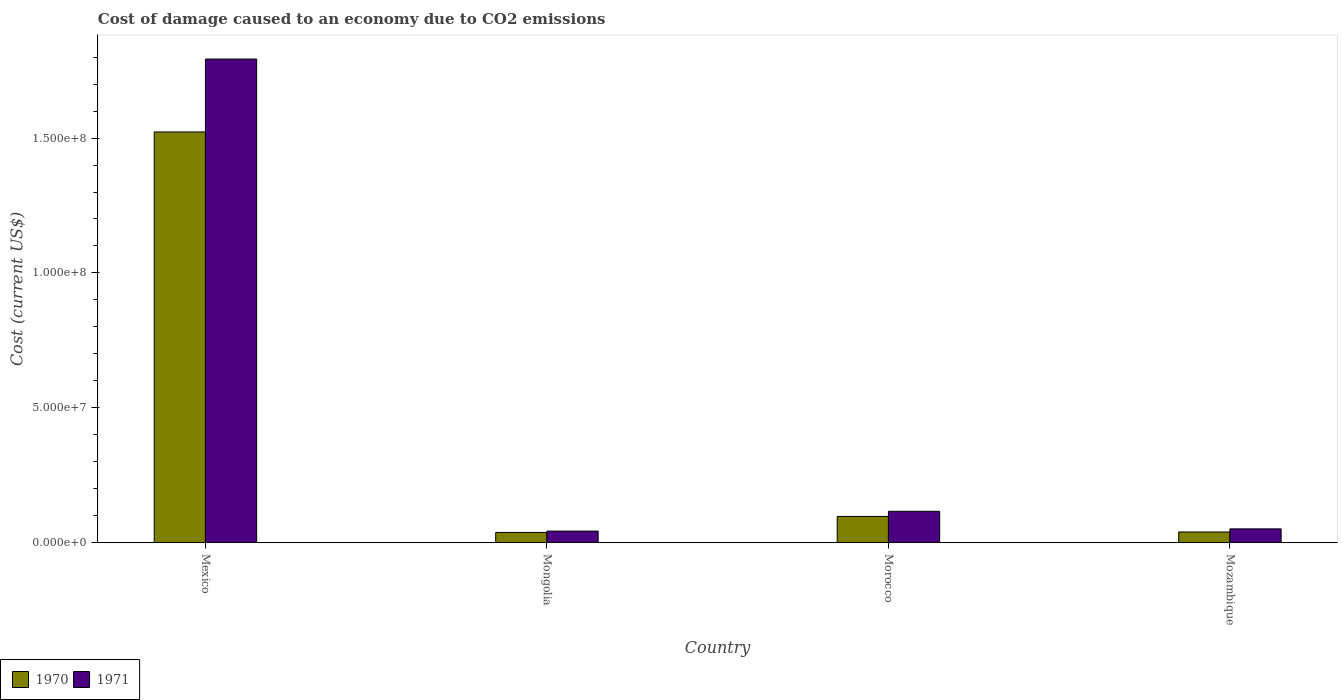How many different coloured bars are there?
Keep it short and to the point. 2. Are the number of bars per tick equal to the number of legend labels?
Offer a very short reply. Yes. How many bars are there on the 4th tick from the right?
Provide a short and direct response. 2. What is the label of the 4th group of bars from the left?
Ensure brevity in your answer.  Mozambique. In how many cases, is the number of bars for a given country not equal to the number of legend labels?
Your answer should be very brief. 0. What is the cost of damage caused due to CO2 emissisons in 1970 in Mongolia?
Provide a succinct answer. 3.80e+06. Across all countries, what is the maximum cost of damage caused due to CO2 emissisons in 1970?
Your answer should be compact. 1.52e+08. Across all countries, what is the minimum cost of damage caused due to CO2 emissisons in 1970?
Make the answer very short. 3.80e+06. In which country was the cost of damage caused due to CO2 emissisons in 1971 minimum?
Give a very brief answer. Mongolia. What is the total cost of damage caused due to CO2 emissisons in 1971 in the graph?
Your response must be concise. 2.00e+08. What is the difference between the cost of damage caused due to CO2 emissisons in 1970 in Mongolia and that in Morocco?
Ensure brevity in your answer.  -5.93e+06. What is the difference between the cost of damage caused due to CO2 emissisons in 1971 in Morocco and the cost of damage caused due to CO2 emissisons in 1970 in Mozambique?
Your response must be concise. 7.66e+06. What is the average cost of damage caused due to CO2 emissisons in 1971 per country?
Offer a terse response. 5.01e+07. What is the difference between the cost of damage caused due to CO2 emissisons of/in 1971 and cost of damage caused due to CO2 emissisons of/in 1970 in Mongolia?
Make the answer very short. 5.05e+05. In how many countries, is the cost of damage caused due to CO2 emissisons in 1971 greater than 90000000 US$?
Provide a succinct answer. 1. What is the ratio of the cost of damage caused due to CO2 emissisons in 1971 in Mexico to that in Morocco?
Provide a succinct answer. 15.4. Is the difference between the cost of damage caused due to CO2 emissisons in 1971 in Mexico and Mongolia greater than the difference between the cost of damage caused due to CO2 emissisons in 1970 in Mexico and Mongolia?
Offer a very short reply. Yes. What is the difference between the highest and the second highest cost of damage caused due to CO2 emissisons in 1971?
Your response must be concise. 1.68e+08. What is the difference between the highest and the lowest cost of damage caused due to CO2 emissisons in 1970?
Offer a very short reply. 1.48e+08. In how many countries, is the cost of damage caused due to CO2 emissisons in 1971 greater than the average cost of damage caused due to CO2 emissisons in 1971 taken over all countries?
Your response must be concise. 1. What does the 1st bar from the left in Mongolia represents?
Make the answer very short. 1970. What does the 2nd bar from the right in Mexico represents?
Your answer should be very brief. 1970. How many bars are there?
Give a very brief answer. 8. Are all the bars in the graph horizontal?
Your response must be concise. No. How many countries are there in the graph?
Provide a succinct answer. 4. Are the values on the major ticks of Y-axis written in scientific E-notation?
Your response must be concise. Yes. Where does the legend appear in the graph?
Provide a succinct answer. Bottom left. How many legend labels are there?
Ensure brevity in your answer.  2. How are the legend labels stacked?
Your answer should be compact. Horizontal. What is the title of the graph?
Make the answer very short. Cost of damage caused to an economy due to CO2 emissions. What is the label or title of the Y-axis?
Your answer should be compact. Cost (current US$). What is the Cost (current US$) in 1970 in Mexico?
Ensure brevity in your answer.  1.52e+08. What is the Cost (current US$) in 1971 in Mexico?
Your response must be concise. 1.79e+08. What is the Cost (current US$) in 1970 in Mongolia?
Provide a succinct answer. 3.80e+06. What is the Cost (current US$) in 1971 in Mongolia?
Provide a succinct answer. 4.31e+06. What is the Cost (current US$) of 1970 in Morocco?
Provide a short and direct response. 9.74e+06. What is the Cost (current US$) in 1971 in Morocco?
Provide a short and direct response. 1.16e+07. What is the Cost (current US$) in 1970 in Mozambique?
Give a very brief answer. 3.98e+06. What is the Cost (current US$) of 1971 in Mozambique?
Your response must be concise. 5.13e+06. Across all countries, what is the maximum Cost (current US$) of 1970?
Your response must be concise. 1.52e+08. Across all countries, what is the maximum Cost (current US$) in 1971?
Your response must be concise. 1.79e+08. Across all countries, what is the minimum Cost (current US$) in 1970?
Make the answer very short. 3.80e+06. Across all countries, what is the minimum Cost (current US$) in 1971?
Keep it short and to the point. 4.31e+06. What is the total Cost (current US$) of 1970 in the graph?
Make the answer very short. 1.70e+08. What is the total Cost (current US$) in 1971 in the graph?
Make the answer very short. 2.00e+08. What is the difference between the Cost (current US$) of 1970 in Mexico and that in Mongolia?
Ensure brevity in your answer.  1.48e+08. What is the difference between the Cost (current US$) of 1971 in Mexico and that in Mongolia?
Keep it short and to the point. 1.75e+08. What is the difference between the Cost (current US$) of 1970 in Mexico and that in Morocco?
Keep it short and to the point. 1.43e+08. What is the difference between the Cost (current US$) in 1971 in Mexico and that in Morocco?
Give a very brief answer. 1.68e+08. What is the difference between the Cost (current US$) of 1970 in Mexico and that in Mozambique?
Your answer should be very brief. 1.48e+08. What is the difference between the Cost (current US$) in 1971 in Mexico and that in Mozambique?
Your answer should be very brief. 1.74e+08. What is the difference between the Cost (current US$) in 1970 in Mongolia and that in Morocco?
Make the answer very short. -5.93e+06. What is the difference between the Cost (current US$) in 1971 in Mongolia and that in Morocco?
Offer a terse response. -7.33e+06. What is the difference between the Cost (current US$) in 1970 in Mongolia and that in Mozambique?
Offer a very short reply. -1.81e+05. What is the difference between the Cost (current US$) of 1971 in Mongolia and that in Mozambique?
Offer a terse response. -8.22e+05. What is the difference between the Cost (current US$) in 1970 in Morocco and that in Mozambique?
Ensure brevity in your answer.  5.75e+06. What is the difference between the Cost (current US$) of 1971 in Morocco and that in Mozambique?
Provide a succinct answer. 6.51e+06. What is the difference between the Cost (current US$) of 1970 in Mexico and the Cost (current US$) of 1971 in Mongolia?
Your answer should be very brief. 1.48e+08. What is the difference between the Cost (current US$) of 1970 in Mexico and the Cost (current US$) of 1971 in Morocco?
Ensure brevity in your answer.  1.41e+08. What is the difference between the Cost (current US$) of 1970 in Mexico and the Cost (current US$) of 1971 in Mozambique?
Offer a very short reply. 1.47e+08. What is the difference between the Cost (current US$) in 1970 in Mongolia and the Cost (current US$) in 1971 in Morocco?
Make the answer very short. -7.84e+06. What is the difference between the Cost (current US$) of 1970 in Mongolia and the Cost (current US$) of 1971 in Mozambique?
Ensure brevity in your answer.  -1.33e+06. What is the difference between the Cost (current US$) of 1970 in Morocco and the Cost (current US$) of 1971 in Mozambique?
Your answer should be very brief. 4.60e+06. What is the average Cost (current US$) of 1970 per country?
Offer a terse response. 4.24e+07. What is the average Cost (current US$) in 1971 per country?
Ensure brevity in your answer.  5.01e+07. What is the difference between the Cost (current US$) in 1970 and Cost (current US$) in 1971 in Mexico?
Give a very brief answer. -2.70e+07. What is the difference between the Cost (current US$) of 1970 and Cost (current US$) of 1971 in Mongolia?
Make the answer very short. -5.05e+05. What is the difference between the Cost (current US$) in 1970 and Cost (current US$) in 1971 in Morocco?
Offer a very short reply. -1.91e+06. What is the difference between the Cost (current US$) of 1970 and Cost (current US$) of 1971 in Mozambique?
Ensure brevity in your answer.  -1.15e+06. What is the ratio of the Cost (current US$) in 1970 in Mexico to that in Mongolia?
Offer a terse response. 40.04. What is the ratio of the Cost (current US$) in 1971 in Mexico to that in Mongolia?
Your answer should be compact. 41.61. What is the ratio of the Cost (current US$) of 1970 in Mexico to that in Morocco?
Keep it short and to the point. 15.64. What is the ratio of the Cost (current US$) in 1971 in Mexico to that in Morocco?
Make the answer very short. 15.4. What is the ratio of the Cost (current US$) in 1970 in Mexico to that in Mozambique?
Offer a terse response. 38.22. What is the ratio of the Cost (current US$) of 1971 in Mexico to that in Mozambique?
Offer a very short reply. 34.94. What is the ratio of the Cost (current US$) of 1970 in Mongolia to that in Morocco?
Keep it short and to the point. 0.39. What is the ratio of the Cost (current US$) in 1971 in Mongolia to that in Morocco?
Ensure brevity in your answer.  0.37. What is the ratio of the Cost (current US$) of 1970 in Mongolia to that in Mozambique?
Offer a very short reply. 0.95. What is the ratio of the Cost (current US$) of 1971 in Mongolia to that in Mozambique?
Give a very brief answer. 0.84. What is the ratio of the Cost (current US$) of 1970 in Morocco to that in Mozambique?
Provide a succinct answer. 2.44. What is the ratio of the Cost (current US$) of 1971 in Morocco to that in Mozambique?
Your response must be concise. 2.27. What is the difference between the highest and the second highest Cost (current US$) in 1970?
Your answer should be very brief. 1.43e+08. What is the difference between the highest and the second highest Cost (current US$) in 1971?
Offer a very short reply. 1.68e+08. What is the difference between the highest and the lowest Cost (current US$) of 1970?
Offer a very short reply. 1.48e+08. What is the difference between the highest and the lowest Cost (current US$) of 1971?
Make the answer very short. 1.75e+08. 